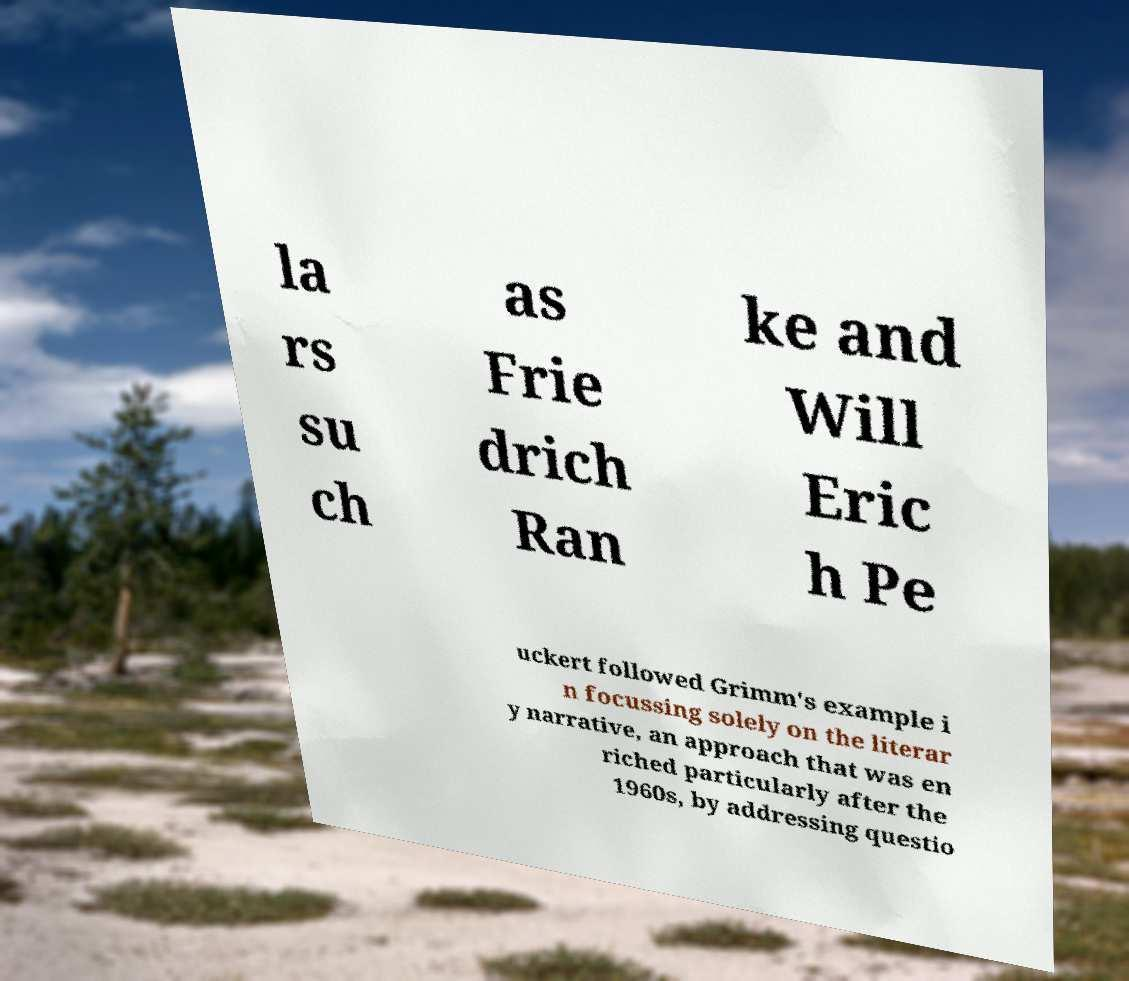Could you assist in decoding the text presented in this image and type it out clearly? la rs su ch as Frie drich Ran ke and Will Eric h Pe uckert followed Grimm's example i n focussing solely on the literar y narrative, an approach that was en riched particularly after the 1960s, by addressing questio 